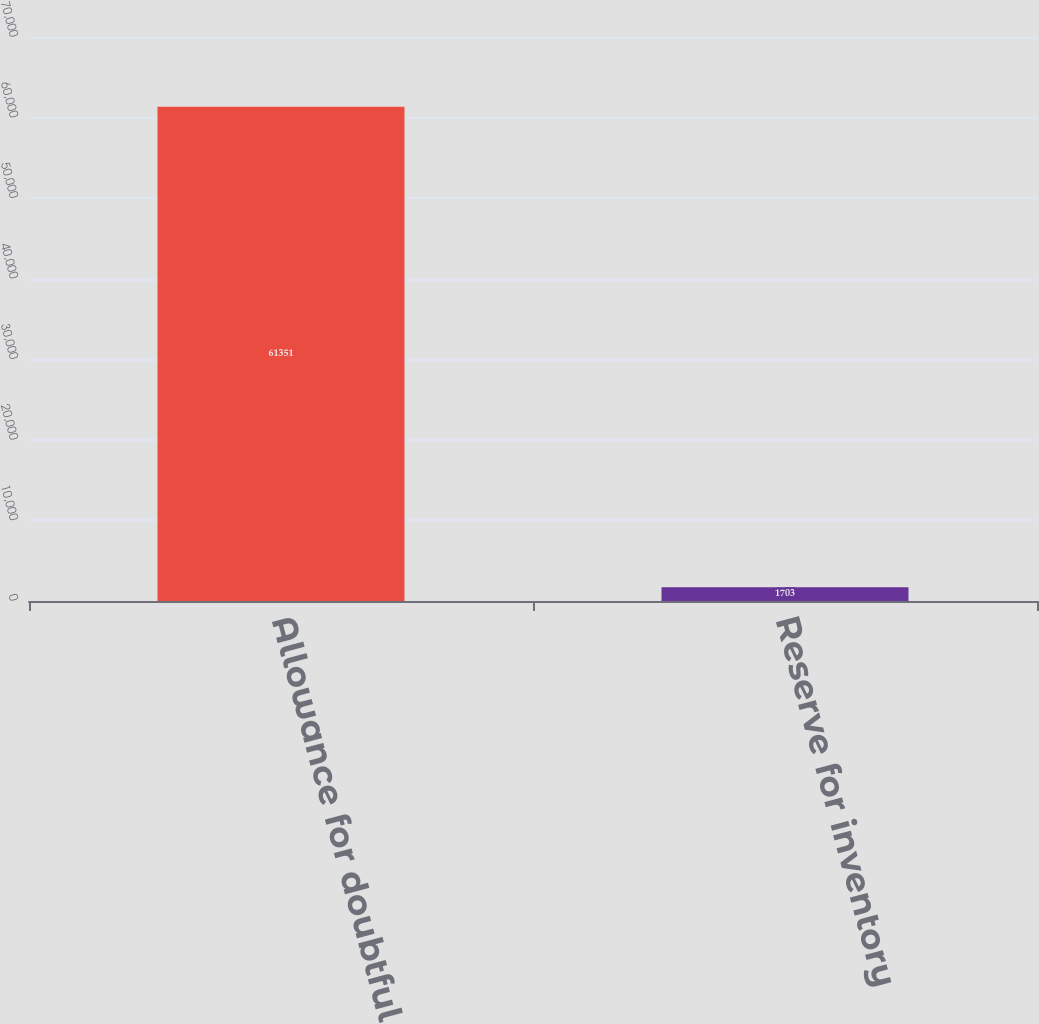Convert chart. <chart><loc_0><loc_0><loc_500><loc_500><bar_chart><fcel>Allowance for doubtful<fcel>Reserve for inventory<nl><fcel>61351<fcel>1703<nl></chart> 